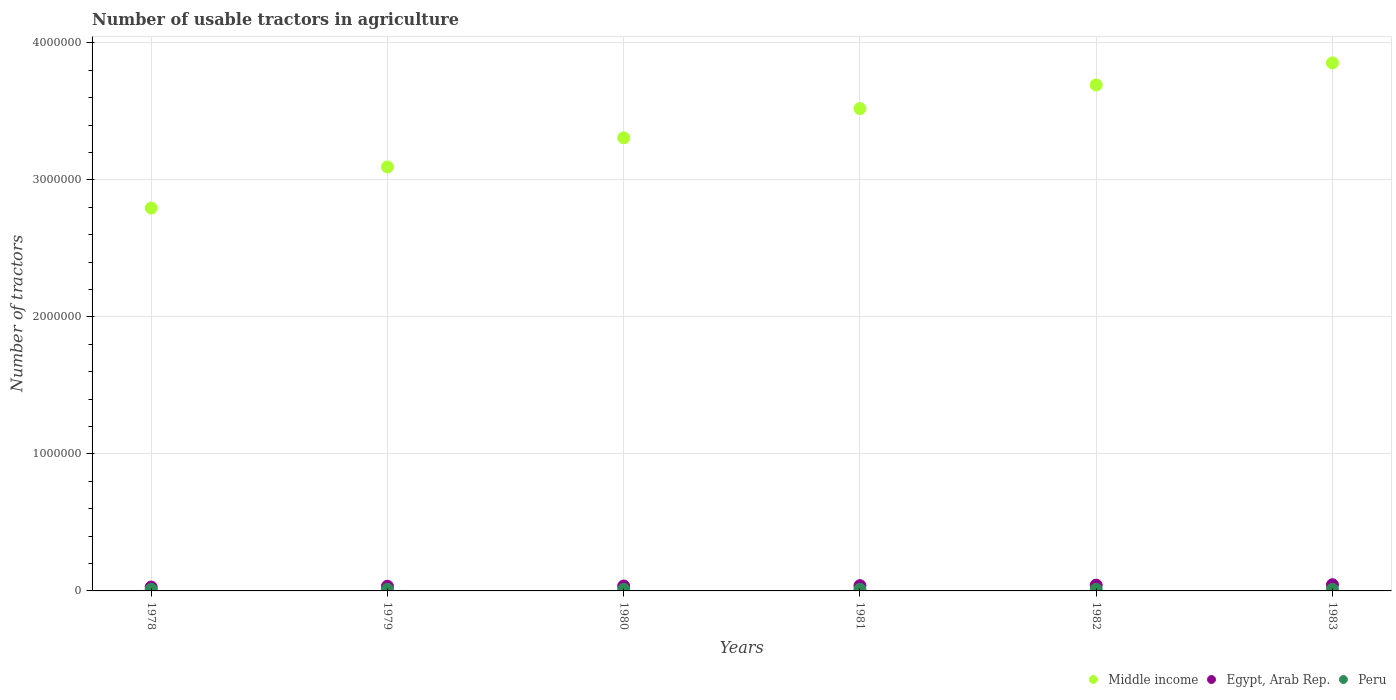How many different coloured dotlines are there?
Your response must be concise. 3. Is the number of dotlines equal to the number of legend labels?
Your answer should be compact. Yes. What is the number of usable tractors in agriculture in Egypt, Arab Rep. in 1980?
Keep it short and to the point. 3.60e+04. Across all years, what is the maximum number of usable tractors in agriculture in Peru?
Give a very brief answer. 1.19e+04. Across all years, what is the minimum number of usable tractors in agriculture in Middle income?
Make the answer very short. 2.79e+06. In which year was the number of usable tractors in agriculture in Peru minimum?
Provide a succinct answer. 1978. What is the total number of usable tractors in agriculture in Middle income in the graph?
Offer a very short reply. 2.03e+07. What is the difference between the number of usable tractors in agriculture in Egypt, Arab Rep. in 1979 and that in 1981?
Offer a terse response. -4450. What is the difference between the number of usable tractors in agriculture in Middle income in 1979 and the number of usable tractors in agriculture in Egypt, Arab Rep. in 1981?
Offer a very short reply. 3.06e+06. What is the average number of usable tractors in agriculture in Peru per year?
Ensure brevity in your answer.  1.19e+04. In the year 1981, what is the difference between the number of usable tractors in agriculture in Middle income and number of usable tractors in agriculture in Egypt, Arab Rep.?
Offer a terse response. 3.48e+06. In how many years, is the number of usable tractors in agriculture in Peru greater than 3600000?
Your answer should be very brief. 0. What is the ratio of the number of usable tractors in agriculture in Egypt, Arab Rep. in 1978 to that in 1981?
Your answer should be compact. 0.73. Is the number of usable tractors in agriculture in Peru in 1978 less than that in 1982?
Offer a very short reply. Yes. What is the difference between the highest and the second highest number of usable tractors in agriculture in Egypt, Arab Rep.?
Offer a terse response. 3300. What is the difference between the highest and the lowest number of usable tractors in agriculture in Egypt, Arab Rep.?
Your response must be concise. 1.69e+04. Is the sum of the number of usable tractors in agriculture in Egypt, Arab Rep. in 1978 and 1981 greater than the maximum number of usable tractors in agriculture in Middle income across all years?
Your answer should be very brief. No. Is it the case that in every year, the sum of the number of usable tractors in agriculture in Peru and number of usable tractors in agriculture in Middle income  is greater than the number of usable tractors in agriculture in Egypt, Arab Rep.?
Provide a succinct answer. Yes. Is the number of usable tractors in agriculture in Middle income strictly greater than the number of usable tractors in agriculture in Peru over the years?
Give a very brief answer. Yes. How many dotlines are there?
Your response must be concise. 3. Does the graph contain grids?
Give a very brief answer. Yes. How are the legend labels stacked?
Provide a succinct answer. Horizontal. What is the title of the graph?
Offer a very short reply. Number of usable tractors in agriculture. What is the label or title of the X-axis?
Your answer should be compact. Years. What is the label or title of the Y-axis?
Offer a terse response. Number of tractors. What is the Number of tractors in Middle income in 1978?
Your answer should be compact. 2.79e+06. What is the Number of tractors of Egypt, Arab Rep. in 1978?
Provide a short and direct response. 2.83e+04. What is the Number of tractors in Peru in 1978?
Offer a very short reply. 1.18e+04. What is the Number of tractors in Middle income in 1979?
Provide a succinct answer. 3.09e+06. What is the Number of tractors of Egypt, Arab Rep. in 1979?
Your answer should be very brief. 3.42e+04. What is the Number of tractors of Peru in 1979?
Offer a very short reply. 1.18e+04. What is the Number of tractors of Middle income in 1980?
Offer a terse response. 3.31e+06. What is the Number of tractors of Egypt, Arab Rep. in 1980?
Your answer should be compact. 3.60e+04. What is the Number of tractors in Peru in 1980?
Your response must be concise. 1.19e+04. What is the Number of tractors of Middle income in 1981?
Provide a succinct answer. 3.52e+06. What is the Number of tractors of Egypt, Arab Rep. in 1981?
Keep it short and to the point. 3.86e+04. What is the Number of tractors in Peru in 1981?
Offer a very short reply. 1.19e+04. What is the Number of tractors in Middle income in 1982?
Provide a short and direct response. 3.69e+06. What is the Number of tractors of Egypt, Arab Rep. in 1982?
Keep it short and to the point. 4.19e+04. What is the Number of tractors in Peru in 1982?
Give a very brief answer. 1.19e+04. What is the Number of tractors of Middle income in 1983?
Your answer should be very brief. 3.85e+06. What is the Number of tractors of Egypt, Arab Rep. in 1983?
Keep it short and to the point. 4.52e+04. What is the Number of tractors of Peru in 1983?
Offer a very short reply. 1.19e+04. Across all years, what is the maximum Number of tractors in Middle income?
Ensure brevity in your answer.  3.85e+06. Across all years, what is the maximum Number of tractors in Egypt, Arab Rep.?
Your response must be concise. 4.52e+04. Across all years, what is the maximum Number of tractors of Peru?
Make the answer very short. 1.19e+04. Across all years, what is the minimum Number of tractors in Middle income?
Keep it short and to the point. 2.79e+06. Across all years, what is the minimum Number of tractors of Egypt, Arab Rep.?
Keep it short and to the point. 2.83e+04. Across all years, what is the minimum Number of tractors in Peru?
Provide a succinct answer. 1.18e+04. What is the total Number of tractors in Middle income in the graph?
Your answer should be very brief. 2.03e+07. What is the total Number of tractors in Egypt, Arab Rep. in the graph?
Ensure brevity in your answer.  2.24e+05. What is the total Number of tractors in Peru in the graph?
Ensure brevity in your answer.  7.12e+04. What is the difference between the Number of tractors in Middle income in 1978 and that in 1979?
Make the answer very short. -3.00e+05. What is the difference between the Number of tractors of Egypt, Arab Rep. in 1978 and that in 1979?
Offer a very short reply. -5889. What is the difference between the Number of tractors in Peru in 1978 and that in 1979?
Give a very brief answer. -50. What is the difference between the Number of tractors of Middle income in 1978 and that in 1980?
Ensure brevity in your answer.  -5.13e+05. What is the difference between the Number of tractors of Egypt, Arab Rep. in 1978 and that in 1980?
Ensure brevity in your answer.  -7700. What is the difference between the Number of tractors in Peru in 1978 and that in 1980?
Make the answer very short. -150. What is the difference between the Number of tractors of Middle income in 1978 and that in 1981?
Provide a succinct answer. -7.26e+05. What is the difference between the Number of tractors in Egypt, Arab Rep. in 1978 and that in 1981?
Keep it short and to the point. -1.03e+04. What is the difference between the Number of tractors in Peru in 1978 and that in 1981?
Offer a very short reply. -150. What is the difference between the Number of tractors in Middle income in 1978 and that in 1982?
Make the answer very short. -8.98e+05. What is the difference between the Number of tractors in Egypt, Arab Rep. in 1978 and that in 1982?
Provide a short and direct response. -1.36e+04. What is the difference between the Number of tractors of Peru in 1978 and that in 1982?
Provide a short and direct response. -150. What is the difference between the Number of tractors of Middle income in 1978 and that in 1983?
Your answer should be very brief. -1.06e+06. What is the difference between the Number of tractors of Egypt, Arab Rep. in 1978 and that in 1983?
Provide a succinct answer. -1.69e+04. What is the difference between the Number of tractors in Peru in 1978 and that in 1983?
Provide a succinct answer. -150. What is the difference between the Number of tractors in Middle income in 1979 and that in 1980?
Offer a terse response. -2.12e+05. What is the difference between the Number of tractors in Egypt, Arab Rep. in 1979 and that in 1980?
Give a very brief answer. -1811. What is the difference between the Number of tractors in Peru in 1979 and that in 1980?
Provide a short and direct response. -100. What is the difference between the Number of tractors of Middle income in 1979 and that in 1981?
Keep it short and to the point. -4.26e+05. What is the difference between the Number of tractors in Egypt, Arab Rep. in 1979 and that in 1981?
Ensure brevity in your answer.  -4450. What is the difference between the Number of tractors of Peru in 1979 and that in 1981?
Your response must be concise. -100. What is the difference between the Number of tractors in Middle income in 1979 and that in 1982?
Give a very brief answer. -5.98e+05. What is the difference between the Number of tractors of Egypt, Arab Rep. in 1979 and that in 1982?
Ensure brevity in your answer.  -7711. What is the difference between the Number of tractors of Peru in 1979 and that in 1982?
Your response must be concise. -100. What is the difference between the Number of tractors of Middle income in 1979 and that in 1983?
Your response must be concise. -7.59e+05. What is the difference between the Number of tractors of Egypt, Arab Rep. in 1979 and that in 1983?
Ensure brevity in your answer.  -1.10e+04. What is the difference between the Number of tractors in Peru in 1979 and that in 1983?
Your answer should be very brief. -100. What is the difference between the Number of tractors of Middle income in 1980 and that in 1981?
Your answer should be compact. -2.13e+05. What is the difference between the Number of tractors in Egypt, Arab Rep. in 1980 and that in 1981?
Ensure brevity in your answer.  -2639. What is the difference between the Number of tractors in Peru in 1980 and that in 1981?
Your answer should be very brief. 0. What is the difference between the Number of tractors of Middle income in 1980 and that in 1982?
Your response must be concise. -3.86e+05. What is the difference between the Number of tractors in Egypt, Arab Rep. in 1980 and that in 1982?
Provide a succinct answer. -5900. What is the difference between the Number of tractors of Peru in 1980 and that in 1982?
Give a very brief answer. 0. What is the difference between the Number of tractors of Middle income in 1980 and that in 1983?
Make the answer very short. -5.47e+05. What is the difference between the Number of tractors in Egypt, Arab Rep. in 1980 and that in 1983?
Give a very brief answer. -9200. What is the difference between the Number of tractors of Middle income in 1981 and that in 1982?
Provide a short and direct response. -1.73e+05. What is the difference between the Number of tractors in Egypt, Arab Rep. in 1981 and that in 1982?
Ensure brevity in your answer.  -3261. What is the difference between the Number of tractors of Peru in 1981 and that in 1982?
Give a very brief answer. 0. What is the difference between the Number of tractors in Middle income in 1981 and that in 1983?
Keep it short and to the point. -3.34e+05. What is the difference between the Number of tractors of Egypt, Arab Rep. in 1981 and that in 1983?
Your answer should be compact. -6561. What is the difference between the Number of tractors of Peru in 1981 and that in 1983?
Provide a succinct answer. 0. What is the difference between the Number of tractors of Middle income in 1982 and that in 1983?
Your answer should be compact. -1.61e+05. What is the difference between the Number of tractors of Egypt, Arab Rep. in 1982 and that in 1983?
Ensure brevity in your answer.  -3300. What is the difference between the Number of tractors of Middle income in 1978 and the Number of tractors of Egypt, Arab Rep. in 1979?
Give a very brief answer. 2.76e+06. What is the difference between the Number of tractors in Middle income in 1978 and the Number of tractors in Peru in 1979?
Make the answer very short. 2.78e+06. What is the difference between the Number of tractors in Egypt, Arab Rep. in 1978 and the Number of tractors in Peru in 1979?
Give a very brief answer. 1.65e+04. What is the difference between the Number of tractors in Middle income in 1978 and the Number of tractors in Egypt, Arab Rep. in 1980?
Provide a succinct answer. 2.76e+06. What is the difference between the Number of tractors of Middle income in 1978 and the Number of tractors of Peru in 1980?
Keep it short and to the point. 2.78e+06. What is the difference between the Number of tractors of Egypt, Arab Rep. in 1978 and the Number of tractors of Peru in 1980?
Make the answer very short. 1.64e+04. What is the difference between the Number of tractors of Middle income in 1978 and the Number of tractors of Egypt, Arab Rep. in 1981?
Make the answer very short. 2.76e+06. What is the difference between the Number of tractors of Middle income in 1978 and the Number of tractors of Peru in 1981?
Give a very brief answer. 2.78e+06. What is the difference between the Number of tractors in Egypt, Arab Rep. in 1978 and the Number of tractors in Peru in 1981?
Provide a short and direct response. 1.64e+04. What is the difference between the Number of tractors of Middle income in 1978 and the Number of tractors of Egypt, Arab Rep. in 1982?
Make the answer very short. 2.75e+06. What is the difference between the Number of tractors in Middle income in 1978 and the Number of tractors in Peru in 1982?
Your response must be concise. 2.78e+06. What is the difference between the Number of tractors of Egypt, Arab Rep. in 1978 and the Number of tractors of Peru in 1982?
Make the answer very short. 1.64e+04. What is the difference between the Number of tractors of Middle income in 1978 and the Number of tractors of Egypt, Arab Rep. in 1983?
Keep it short and to the point. 2.75e+06. What is the difference between the Number of tractors in Middle income in 1978 and the Number of tractors in Peru in 1983?
Give a very brief answer. 2.78e+06. What is the difference between the Number of tractors in Egypt, Arab Rep. in 1978 and the Number of tractors in Peru in 1983?
Provide a short and direct response. 1.64e+04. What is the difference between the Number of tractors of Middle income in 1979 and the Number of tractors of Egypt, Arab Rep. in 1980?
Offer a terse response. 3.06e+06. What is the difference between the Number of tractors of Middle income in 1979 and the Number of tractors of Peru in 1980?
Ensure brevity in your answer.  3.08e+06. What is the difference between the Number of tractors of Egypt, Arab Rep. in 1979 and the Number of tractors of Peru in 1980?
Give a very brief answer. 2.23e+04. What is the difference between the Number of tractors in Middle income in 1979 and the Number of tractors in Egypt, Arab Rep. in 1981?
Keep it short and to the point. 3.06e+06. What is the difference between the Number of tractors of Middle income in 1979 and the Number of tractors of Peru in 1981?
Make the answer very short. 3.08e+06. What is the difference between the Number of tractors of Egypt, Arab Rep. in 1979 and the Number of tractors of Peru in 1981?
Give a very brief answer. 2.23e+04. What is the difference between the Number of tractors in Middle income in 1979 and the Number of tractors in Egypt, Arab Rep. in 1982?
Your answer should be very brief. 3.05e+06. What is the difference between the Number of tractors in Middle income in 1979 and the Number of tractors in Peru in 1982?
Provide a short and direct response. 3.08e+06. What is the difference between the Number of tractors in Egypt, Arab Rep. in 1979 and the Number of tractors in Peru in 1982?
Provide a succinct answer. 2.23e+04. What is the difference between the Number of tractors in Middle income in 1979 and the Number of tractors in Egypt, Arab Rep. in 1983?
Keep it short and to the point. 3.05e+06. What is the difference between the Number of tractors of Middle income in 1979 and the Number of tractors of Peru in 1983?
Your answer should be very brief. 3.08e+06. What is the difference between the Number of tractors in Egypt, Arab Rep. in 1979 and the Number of tractors in Peru in 1983?
Provide a short and direct response. 2.23e+04. What is the difference between the Number of tractors of Middle income in 1980 and the Number of tractors of Egypt, Arab Rep. in 1981?
Provide a succinct answer. 3.27e+06. What is the difference between the Number of tractors in Middle income in 1980 and the Number of tractors in Peru in 1981?
Offer a terse response. 3.29e+06. What is the difference between the Number of tractors in Egypt, Arab Rep. in 1980 and the Number of tractors in Peru in 1981?
Offer a very short reply. 2.41e+04. What is the difference between the Number of tractors in Middle income in 1980 and the Number of tractors in Egypt, Arab Rep. in 1982?
Your answer should be very brief. 3.26e+06. What is the difference between the Number of tractors of Middle income in 1980 and the Number of tractors of Peru in 1982?
Make the answer very short. 3.29e+06. What is the difference between the Number of tractors of Egypt, Arab Rep. in 1980 and the Number of tractors of Peru in 1982?
Make the answer very short. 2.41e+04. What is the difference between the Number of tractors in Middle income in 1980 and the Number of tractors in Egypt, Arab Rep. in 1983?
Provide a short and direct response. 3.26e+06. What is the difference between the Number of tractors in Middle income in 1980 and the Number of tractors in Peru in 1983?
Provide a succinct answer. 3.29e+06. What is the difference between the Number of tractors of Egypt, Arab Rep. in 1980 and the Number of tractors of Peru in 1983?
Give a very brief answer. 2.41e+04. What is the difference between the Number of tractors of Middle income in 1981 and the Number of tractors of Egypt, Arab Rep. in 1982?
Your answer should be very brief. 3.48e+06. What is the difference between the Number of tractors of Middle income in 1981 and the Number of tractors of Peru in 1982?
Offer a terse response. 3.51e+06. What is the difference between the Number of tractors in Egypt, Arab Rep. in 1981 and the Number of tractors in Peru in 1982?
Offer a terse response. 2.67e+04. What is the difference between the Number of tractors of Middle income in 1981 and the Number of tractors of Egypt, Arab Rep. in 1983?
Provide a short and direct response. 3.48e+06. What is the difference between the Number of tractors of Middle income in 1981 and the Number of tractors of Peru in 1983?
Provide a short and direct response. 3.51e+06. What is the difference between the Number of tractors of Egypt, Arab Rep. in 1981 and the Number of tractors of Peru in 1983?
Provide a succinct answer. 2.67e+04. What is the difference between the Number of tractors in Middle income in 1982 and the Number of tractors in Egypt, Arab Rep. in 1983?
Provide a succinct answer. 3.65e+06. What is the difference between the Number of tractors of Middle income in 1982 and the Number of tractors of Peru in 1983?
Provide a short and direct response. 3.68e+06. What is the average Number of tractors in Middle income per year?
Provide a succinct answer. 3.38e+06. What is the average Number of tractors in Egypt, Arab Rep. per year?
Your answer should be very brief. 3.74e+04. What is the average Number of tractors in Peru per year?
Keep it short and to the point. 1.19e+04. In the year 1978, what is the difference between the Number of tractors in Middle income and Number of tractors in Egypt, Arab Rep.?
Keep it short and to the point. 2.77e+06. In the year 1978, what is the difference between the Number of tractors of Middle income and Number of tractors of Peru?
Your response must be concise. 2.78e+06. In the year 1978, what is the difference between the Number of tractors in Egypt, Arab Rep. and Number of tractors in Peru?
Your answer should be very brief. 1.66e+04. In the year 1979, what is the difference between the Number of tractors in Middle income and Number of tractors in Egypt, Arab Rep.?
Provide a succinct answer. 3.06e+06. In the year 1979, what is the difference between the Number of tractors of Middle income and Number of tractors of Peru?
Offer a very short reply. 3.08e+06. In the year 1979, what is the difference between the Number of tractors of Egypt, Arab Rep. and Number of tractors of Peru?
Your answer should be compact. 2.24e+04. In the year 1980, what is the difference between the Number of tractors of Middle income and Number of tractors of Egypt, Arab Rep.?
Your response must be concise. 3.27e+06. In the year 1980, what is the difference between the Number of tractors in Middle income and Number of tractors in Peru?
Your response must be concise. 3.29e+06. In the year 1980, what is the difference between the Number of tractors of Egypt, Arab Rep. and Number of tractors of Peru?
Provide a short and direct response. 2.41e+04. In the year 1981, what is the difference between the Number of tractors of Middle income and Number of tractors of Egypt, Arab Rep.?
Give a very brief answer. 3.48e+06. In the year 1981, what is the difference between the Number of tractors of Middle income and Number of tractors of Peru?
Your answer should be compact. 3.51e+06. In the year 1981, what is the difference between the Number of tractors of Egypt, Arab Rep. and Number of tractors of Peru?
Ensure brevity in your answer.  2.67e+04. In the year 1982, what is the difference between the Number of tractors of Middle income and Number of tractors of Egypt, Arab Rep.?
Offer a very short reply. 3.65e+06. In the year 1982, what is the difference between the Number of tractors in Middle income and Number of tractors in Peru?
Provide a short and direct response. 3.68e+06. In the year 1982, what is the difference between the Number of tractors of Egypt, Arab Rep. and Number of tractors of Peru?
Ensure brevity in your answer.  3.00e+04. In the year 1983, what is the difference between the Number of tractors of Middle income and Number of tractors of Egypt, Arab Rep.?
Your answer should be very brief. 3.81e+06. In the year 1983, what is the difference between the Number of tractors in Middle income and Number of tractors in Peru?
Keep it short and to the point. 3.84e+06. In the year 1983, what is the difference between the Number of tractors of Egypt, Arab Rep. and Number of tractors of Peru?
Your answer should be very brief. 3.33e+04. What is the ratio of the Number of tractors of Middle income in 1978 to that in 1979?
Offer a terse response. 0.9. What is the ratio of the Number of tractors of Egypt, Arab Rep. in 1978 to that in 1979?
Provide a succinct answer. 0.83. What is the ratio of the Number of tractors of Peru in 1978 to that in 1979?
Your answer should be compact. 1. What is the ratio of the Number of tractors in Middle income in 1978 to that in 1980?
Offer a terse response. 0.84. What is the ratio of the Number of tractors of Egypt, Arab Rep. in 1978 to that in 1980?
Your answer should be very brief. 0.79. What is the ratio of the Number of tractors in Peru in 1978 to that in 1980?
Provide a succinct answer. 0.99. What is the ratio of the Number of tractors in Middle income in 1978 to that in 1981?
Offer a terse response. 0.79. What is the ratio of the Number of tractors in Egypt, Arab Rep. in 1978 to that in 1981?
Your answer should be compact. 0.73. What is the ratio of the Number of tractors in Peru in 1978 to that in 1981?
Offer a very short reply. 0.99. What is the ratio of the Number of tractors of Middle income in 1978 to that in 1982?
Provide a short and direct response. 0.76. What is the ratio of the Number of tractors of Egypt, Arab Rep. in 1978 to that in 1982?
Offer a very short reply. 0.68. What is the ratio of the Number of tractors of Peru in 1978 to that in 1982?
Give a very brief answer. 0.99. What is the ratio of the Number of tractors of Middle income in 1978 to that in 1983?
Make the answer very short. 0.73. What is the ratio of the Number of tractors in Egypt, Arab Rep. in 1978 to that in 1983?
Offer a very short reply. 0.63. What is the ratio of the Number of tractors of Peru in 1978 to that in 1983?
Provide a succinct answer. 0.99. What is the ratio of the Number of tractors in Middle income in 1979 to that in 1980?
Offer a terse response. 0.94. What is the ratio of the Number of tractors in Egypt, Arab Rep. in 1979 to that in 1980?
Offer a very short reply. 0.95. What is the ratio of the Number of tractors of Middle income in 1979 to that in 1981?
Offer a very short reply. 0.88. What is the ratio of the Number of tractors of Egypt, Arab Rep. in 1979 to that in 1981?
Keep it short and to the point. 0.88. What is the ratio of the Number of tractors in Peru in 1979 to that in 1981?
Your answer should be compact. 0.99. What is the ratio of the Number of tractors of Middle income in 1979 to that in 1982?
Your answer should be compact. 0.84. What is the ratio of the Number of tractors in Egypt, Arab Rep. in 1979 to that in 1982?
Your answer should be compact. 0.82. What is the ratio of the Number of tractors in Peru in 1979 to that in 1982?
Offer a terse response. 0.99. What is the ratio of the Number of tractors of Middle income in 1979 to that in 1983?
Offer a terse response. 0.8. What is the ratio of the Number of tractors of Egypt, Arab Rep. in 1979 to that in 1983?
Provide a short and direct response. 0.76. What is the ratio of the Number of tractors of Middle income in 1980 to that in 1981?
Your answer should be very brief. 0.94. What is the ratio of the Number of tractors of Egypt, Arab Rep. in 1980 to that in 1981?
Keep it short and to the point. 0.93. What is the ratio of the Number of tractors in Peru in 1980 to that in 1981?
Offer a terse response. 1. What is the ratio of the Number of tractors of Middle income in 1980 to that in 1982?
Keep it short and to the point. 0.9. What is the ratio of the Number of tractors of Egypt, Arab Rep. in 1980 to that in 1982?
Your answer should be very brief. 0.86. What is the ratio of the Number of tractors in Peru in 1980 to that in 1982?
Ensure brevity in your answer.  1. What is the ratio of the Number of tractors in Middle income in 1980 to that in 1983?
Provide a short and direct response. 0.86. What is the ratio of the Number of tractors in Egypt, Arab Rep. in 1980 to that in 1983?
Your response must be concise. 0.8. What is the ratio of the Number of tractors of Middle income in 1981 to that in 1982?
Your answer should be compact. 0.95. What is the ratio of the Number of tractors of Egypt, Arab Rep. in 1981 to that in 1982?
Offer a very short reply. 0.92. What is the ratio of the Number of tractors of Peru in 1981 to that in 1982?
Keep it short and to the point. 1. What is the ratio of the Number of tractors of Middle income in 1981 to that in 1983?
Your answer should be very brief. 0.91. What is the ratio of the Number of tractors of Egypt, Arab Rep. in 1981 to that in 1983?
Provide a short and direct response. 0.85. What is the ratio of the Number of tractors of Peru in 1981 to that in 1983?
Provide a short and direct response. 1. What is the ratio of the Number of tractors of Middle income in 1982 to that in 1983?
Your response must be concise. 0.96. What is the ratio of the Number of tractors of Egypt, Arab Rep. in 1982 to that in 1983?
Your response must be concise. 0.93. What is the ratio of the Number of tractors in Peru in 1982 to that in 1983?
Provide a short and direct response. 1. What is the difference between the highest and the second highest Number of tractors of Middle income?
Your answer should be compact. 1.61e+05. What is the difference between the highest and the second highest Number of tractors in Egypt, Arab Rep.?
Your response must be concise. 3300. What is the difference between the highest and the lowest Number of tractors of Middle income?
Your answer should be compact. 1.06e+06. What is the difference between the highest and the lowest Number of tractors of Egypt, Arab Rep.?
Ensure brevity in your answer.  1.69e+04. What is the difference between the highest and the lowest Number of tractors of Peru?
Ensure brevity in your answer.  150. 